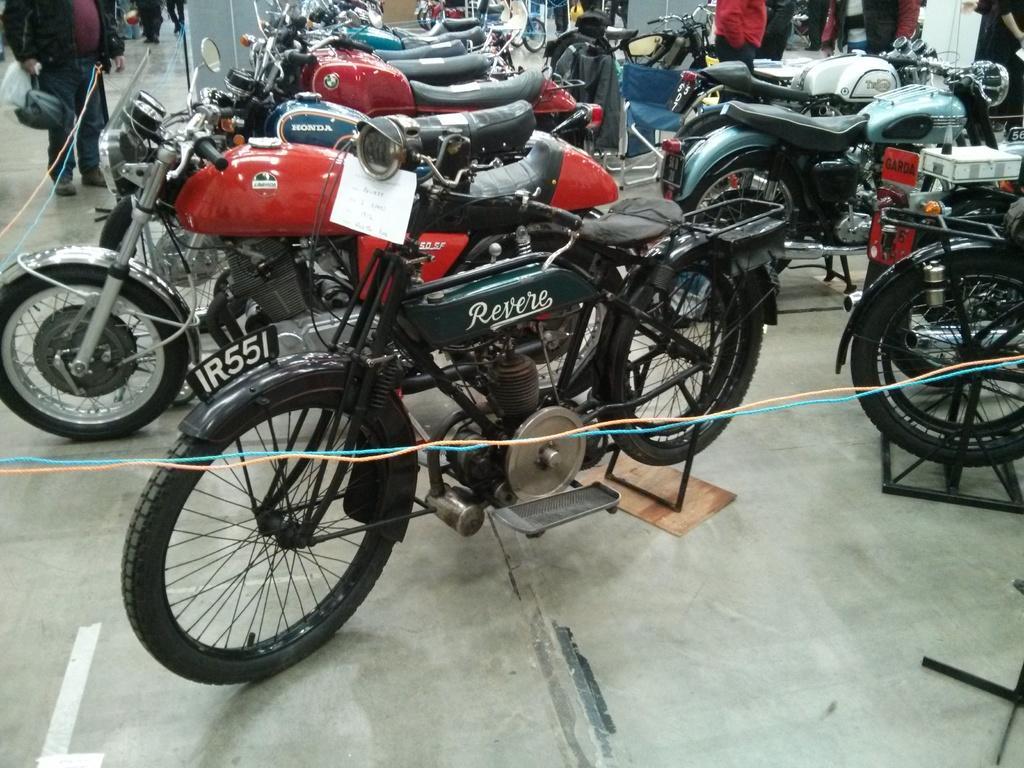Please provide a concise description of this image. This image consists of many bikes. In the front, we can see a bike in green color. At the bottom, there is a floor. On the left, we can see a person holding a bag and standing. 